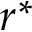<formula> <loc_0><loc_0><loc_500><loc_500>r ^ { * }</formula> 